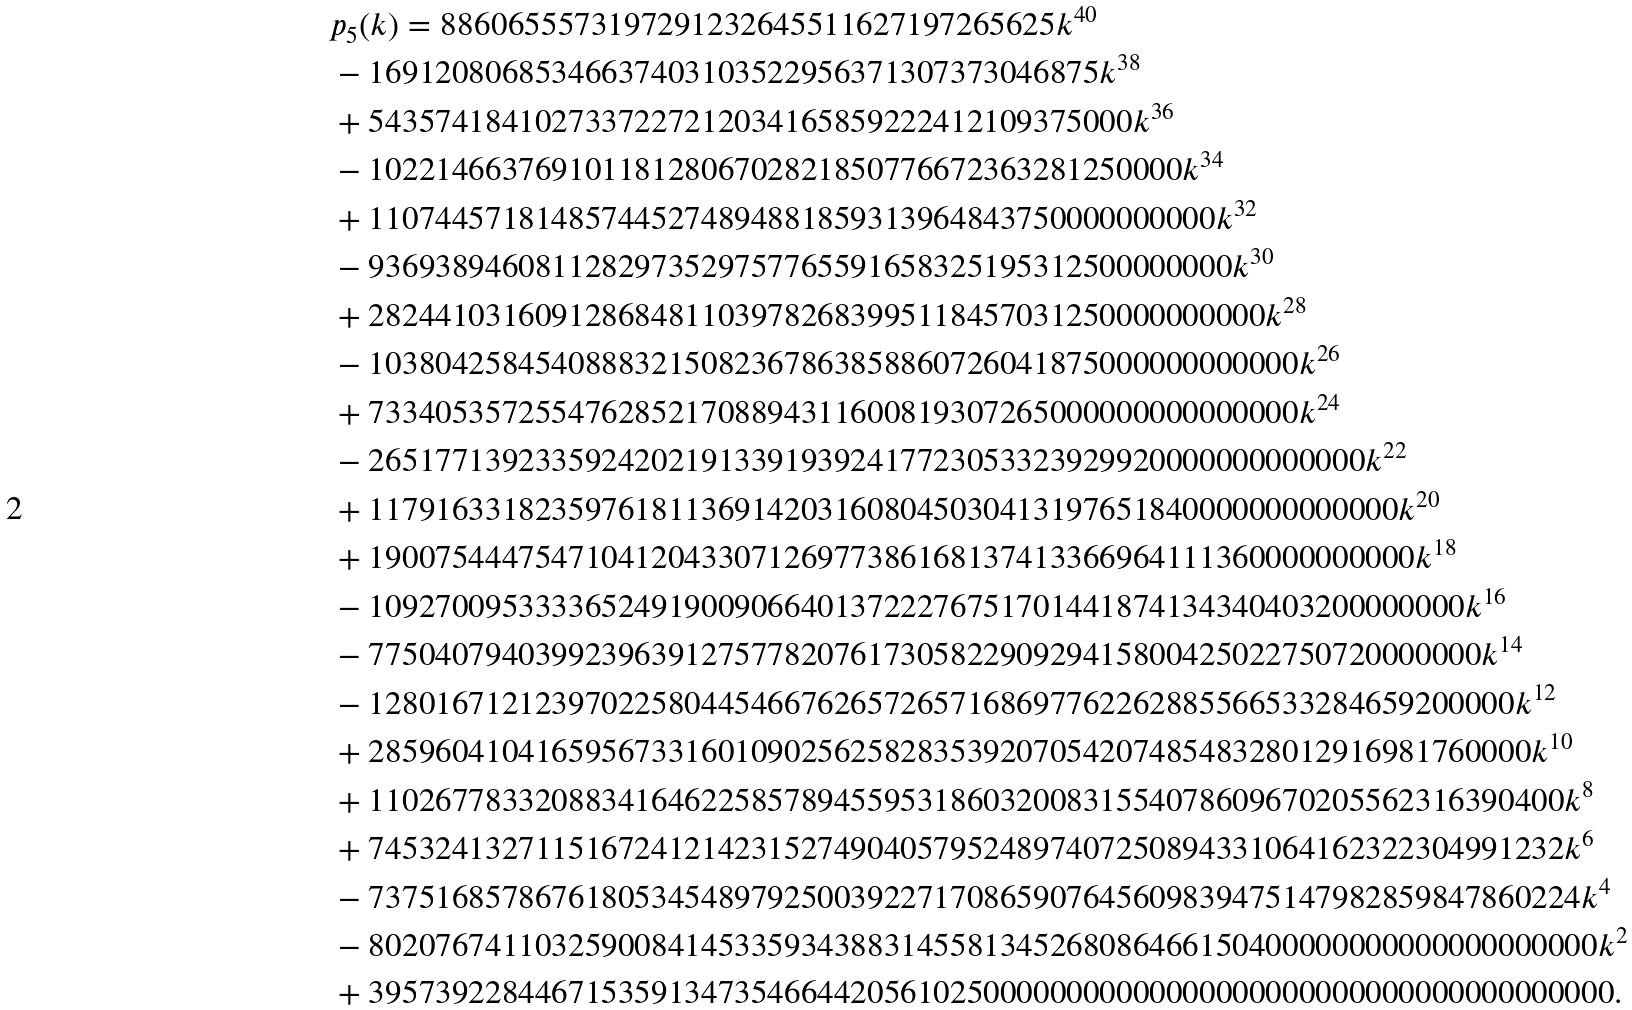<formula> <loc_0><loc_0><loc_500><loc_500>& p _ { 5 } ( k ) = 8 8 6 0 6 5 5 5 7 3 1 9 7 2 9 1 2 3 2 6 4 5 5 1 1 6 2 7 1 9 7 2 6 5 6 2 5 k ^ { 4 0 } \\ & - 1 6 9 1 2 0 8 0 6 8 5 3 4 6 6 3 7 4 0 3 1 0 3 5 2 2 9 5 6 3 7 1 3 0 7 3 7 3 0 4 6 8 7 5 k ^ { 3 8 } \\ & + 5 4 3 5 7 4 1 8 4 1 0 2 7 3 3 7 2 2 7 2 1 2 0 3 4 1 6 5 8 5 9 2 2 2 4 1 2 1 0 9 3 7 5 0 0 0 k ^ { 3 6 } \\ & - 1 0 2 2 1 4 6 6 3 7 6 9 1 0 1 1 8 1 2 8 0 6 7 0 2 8 2 1 8 5 0 7 7 6 6 7 2 3 6 3 2 8 1 2 5 0 0 0 0 k ^ { 3 4 } \\ & + 1 1 0 7 4 4 5 7 1 8 1 4 8 5 7 4 4 5 2 7 4 8 9 4 8 8 1 8 5 9 3 1 3 9 6 4 8 4 3 7 5 0 0 0 0 0 0 0 0 0 0 k ^ { 3 2 } \\ & - 9 3 6 9 3 8 9 4 6 0 8 1 1 2 8 2 9 7 3 5 2 9 7 5 7 7 6 5 5 9 1 6 5 8 3 2 5 1 9 5 3 1 2 5 0 0 0 0 0 0 0 0 k ^ { 3 0 } \\ & + 2 8 2 4 4 1 0 3 1 6 0 9 1 2 8 6 8 4 8 1 1 0 3 9 7 8 2 6 8 3 9 9 5 1 1 8 4 5 7 0 3 1 2 5 0 0 0 0 0 0 0 0 0 0 k ^ { 2 8 } \\ & - 1 0 3 8 0 4 2 5 8 4 5 4 0 8 8 8 3 2 1 5 0 8 2 3 6 7 8 6 3 8 5 8 8 6 0 7 2 6 0 4 1 8 7 5 0 0 0 0 0 0 0 0 0 0 0 0 k ^ { 2 6 } \\ & + 7 3 3 4 0 5 3 5 7 2 5 5 4 7 6 2 8 5 2 1 7 0 8 8 9 4 3 1 1 6 0 0 8 1 9 3 0 7 2 6 5 0 0 0 0 0 0 0 0 0 0 0 0 0 0 0 k ^ { 2 4 } \\ & - 2 6 5 1 7 7 1 3 9 2 3 3 5 9 2 4 2 0 2 1 9 1 3 3 9 1 9 3 9 2 4 1 7 7 2 3 0 5 3 3 2 3 9 2 9 9 2 0 0 0 0 0 0 0 0 0 0 0 0 0 k ^ { 2 2 } \\ & + 1 1 7 9 1 6 3 3 1 8 2 3 5 9 7 6 1 8 1 1 3 6 9 1 4 2 0 3 1 6 0 8 0 4 5 0 3 0 4 1 3 1 9 7 6 5 1 8 4 0 0 0 0 0 0 0 0 0 0 0 0 0 k ^ { 2 0 } \\ & + 1 9 0 0 7 5 4 4 4 7 5 4 7 1 0 4 1 2 0 4 3 3 0 7 1 2 6 9 7 7 3 8 6 1 6 8 1 3 7 4 1 3 3 6 6 9 6 4 1 1 1 3 6 0 0 0 0 0 0 0 0 0 0 k ^ { 1 8 } \\ & - 1 0 9 2 7 0 0 9 5 3 3 3 3 6 5 2 4 9 1 9 0 0 9 0 6 6 4 0 1 3 7 2 2 2 7 6 7 5 1 7 0 1 4 4 1 8 7 4 1 3 4 3 4 0 4 0 3 2 0 0 0 0 0 0 0 0 k ^ { 1 6 } \\ & - 7 7 5 0 4 0 7 9 4 0 3 9 9 2 3 9 6 3 9 1 2 7 5 7 7 8 2 0 7 6 1 7 3 0 5 8 2 2 9 0 9 2 9 4 1 5 8 0 0 4 2 5 0 2 2 7 5 0 7 2 0 0 0 0 0 0 0 k ^ { 1 4 } \\ & - 1 2 8 0 1 6 7 1 2 1 2 3 9 7 0 2 2 5 8 0 4 4 5 4 6 6 7 6 2 6 5 7 2 6 5 7 1 6 8 6 9 7 7 6 2 2 6 2 8 8 5 5 6 6 5 3 3 2 8 4 6 5 9 2 0 0 0 0 0 k ^ { 1 2 } \\ & + 2 8 5 9 6 0 4 1 0 4 1 6 5 9 5 6 7 3 3 1 6 0 1 0 9 0 2 5 6 2 5 8 2 8 3 5 3 9 2 0 7 0 5 4 2 0 7 4 8 5 4 8 3 2 8 0 1 2 9 1 6 9 8 1 7 6 0 0 0 0 k ^ { 1 0 } \\ & + 1 1 0 2 6 7 7 8 3 3 2 0 8 8 3 4 1 6 4 6 2 2 5 8 5 7 8 9 4 5 5 9 5 3 1 8 6 0 3 2 0 0 8 3 1 5 5 4 0 7 8 6 0 9 6 7 0 2 0 5 5 6 2 3 1 6 3 9 0 4 0 0 k ^ { 8 } \\ & + 7 4 5 3 2 4 1 3 2 7 1 1 5 1 6 7 2 4 1 2 1 4 2 3 1 5 2 7 4 9 0 4 0 5 7 9 5 2 4 8 9 7 4 0 7 2 5 0 8 9 4 3 3 1 0 6 4 1 6 2 3 2 2 3 0 4 9 9 1 2 3 2 k ^ { 6 } \\ & - 7 3 7 5 1 6 8 5 7 8 6 7 6 1 8 0 5 3 4 5 4 8 9 7 9 2 5 0 0 3 9 2 2 7 1 7 0 8 6 5 9 0 7 6 4 5 6 0 9 8 3 9 4 7 5 1 4 7 9 8 2 8 5 9 8 4 7 8 6 0 2 2 4 k ^ { 4 } \\ & - 8 0 2 0 7 6 7 4 1 1 0 3 2 5 9 0 0 8 4 1 4 5 3 3 5 9 3 4 3 8 8 3 1 4 5 5 8 1 3 4 5 2 6 8 0 8 6 4 6 6 1 5 0 4 0 0 0 0 0 0 0 0 0 0 0 0 0 0 0 0 0 0 0 0 k ^ { 2 } \\ & + 3 9 5 7 3 9 2 2 8 4 4 6 7 1 5 3 5 9 1 3 4 7 3 5 4 6 6 4 4 2 0 5 6 1 0 2 5 0 0 0 0 0 0 0 0 0 0 0 0 0 0 0 0 0 0 0 0 0 0 0 0 0 0 0 0 0 0 0 0 0 0 0 0 0 0 .</formula> 